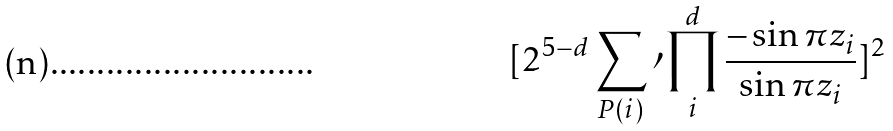<formula> <loc_0><loc_0><loc_500><loc_500>[ 2 ^ { 5 - d } \sum _ { P ( i ) } \prime \prod _ { i } ^ { d } \frac { - \sin \pi z _ { i } } { \sin \pi z _ { i } } ] ^ { 2 }</formula> 